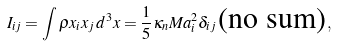<formula> <loc_0><loc_0><loc_500><loc_500>I _ { i j } = \int \rho x _ { i } x _ { j } \, d ^ { 3 } x = \frac { 1 } { 5 } \kappa _ { n } M a _ { i } ^ { 2 } \delta _ { i j } \, \text {(no sum)} \, ,</formula> 